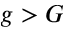Convert formula to latex. <formula><loc_0><loc_0><loc_500><loc_500>g > G</formula> 